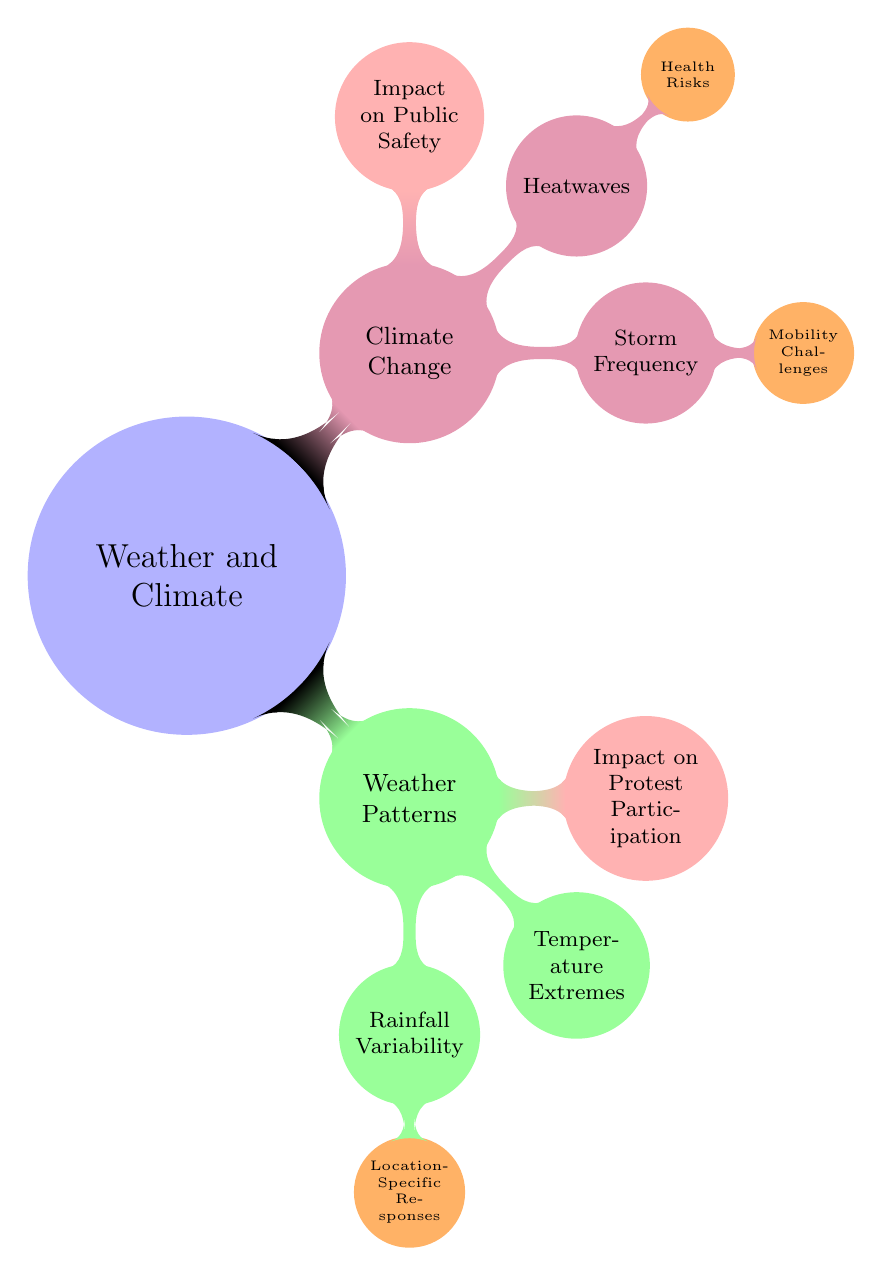What is the main topic of the diagram? The main topic of the diagram is "Weather and Climate," which is the starting node.
Answer: Weather and Climate How many child nodes does "Weather Patterns" have? The node "Weather Patterns" branches into three child nodes: "Rainfall Variability," "Temperature Extremes," and "Impact on Protest Participation," totaling three.
Answer: 3 What color represents "Impact on Protest Participation"? The node "Impact on Protest Participation" is colored red, consistent with the diagram's color-coding for that category.
Answer: Red Which node is a child of "Storm Frequency"? The child node of "Storm Frequency" is "Mobility Challenges." This can be found directly beneath the "Storm Frequency" node.
Answer: Mobility Challenges What are the health risks associated with "Heatwaves"? The "Health Risks" associated with "Heatwaves" are specified as a child node under the "Heatwaves" category.
Answer: Health Risks How many total nodes are under "Climate Change"? The "Climate Change" node has three child nodes: "Storm Frequency," "Heatwaves," and "Impact on Public Safety," which totals to three.
Answer: 3 Which two categories directly influence "Impact on Protest Participation"? The two categories that influence "Impact on Protest Participation" are "Weather Patterns" and "Climate Change," as they both lead to this node.
Answer: Weather Patterns and Climate Change What is the relationship between "Temperature Extremes" and "Impact on Protest Participation"? "Temperature Extremes" is a direct influence on "Impact on Protest Participation," as both are within the "Weather Patterns" category.
Answer: Direct influence Which concept is placed at the top level of the diagram? The concept at the top level is "Weather and Climate," as it serves as the root node of the diagram.
Answer: Weather and Climate 